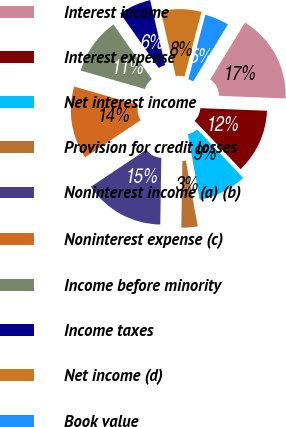<chart> <loc_0><loc_0><loc_500><loc_500><pie_chart><fcel>Interest income<fcel>Interest expense<fcel>Net interest income<fcel>Provision for credit losses<fcel>Noninterest income (a) (b)<fcel>Noninterest expense (c)<fcel>Income before minority<fcel>Income taxes<fcel>Net income (d)<fcel>Book value<nl><fcel>16.91%<fcel>12.3%<fcel>9.23%<fcel>3.09%<fcel>15.38%<fcel>13.84%<fcel>10.77%<fcel>6.16%<fcel>7.7%<fcel>4.62%<nl></chart> 